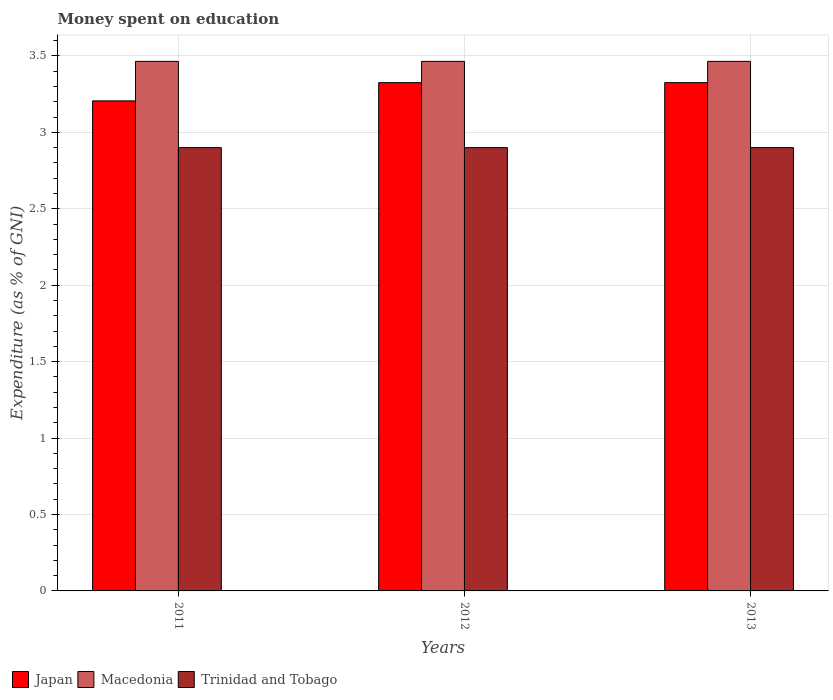How many different coloured bars are there?
Your response must be concise. 3. How many groups of bars are there?
Your answer should be compact. 3. Are the number of bars per tick equal to the number of legend labels?
Offer a very short reply. Yes. Are the number of bars on each tick of the X-axis equal?
Offer a terse response. Yes. In how many cases, is the number of bars for a given year not equal to the number of legend labels?
Provide a succinct answer. 0. What is the amount of money spent on education in Japan in 2011?
Give a very brief answer. 3.21. Across all years, what is the maximum amount of money spent on education in Macedonia?
Offer a very short reply. 3.46. Across all years, what is the minimum amount of money spent on education in Macedonia?
Provide a succinct answer. 3.46. In which year was the amount of money spent on education in Macedonia maximum?
Keep it short and to the point. 2011. In which year was the amount of money spent on education in Macedonia minimum?
Provide a succinct answer. 2011. What is the difference between the amount of money spent on education in Trinidad and Tobago in 2011 and the amount of money spent on education in Japan in 2012?
Provide a short and direct response. -0.43. What is the average amount of money spent on education in Japan per year?
Give a very brief answer. 3.29. In the year 2011, what is the difference between the amount of money spent on education in Trinidad and Tobago and amount of money spent on education in Macedonia?
Ensure brevity in your answer.  -0.56. In how many years, is the amount of money spent on education in Japan greater than 0.30000000000000004 %?
Ensure brevity in your answer.  3. What is the ratio of the amount of money spent on education in Japan in 2012 to that in 2013?
Your answer should be compact. 1. Is the amount of money spent on education in Macedonia in 2011 less than that in 2013?
Ensure brevity in your answer.  No. Is the difference between the amount of money spent on education in Trinidad and Tobago in 2011 and 2013 greater than the difference between the amount of money spent on education in Macedonia in 2011 and 2013?
Make the answer very short. No. What is the difference between the highest and the second highest amount of money spent on education in Trinidad and Tobago?
Provide a short and direct response. 0. What is the difference between the highest and the lowest amount of money spent on education in Japan?
Offer a terse response. 0.12. In how many years, is the amount of money spent on education in Macedonia greater than the average amount of money spent on education in Macedonia taken over all years?
Your response must be concise. 0. What does the 2nd bar from the left in 2011 represents?
Ensure brevity in your answer.  Macedonia. What does the 2nd bar from the right in 2013 represents?
Offer a terse response. Macedonia. How many bars are there?
Offer a very short reply. 9. How many years are there in the graph?
Your answer should be compact. 3. What is the difference between two consecutive major ticks on the Y-axis?
Your answer should be compact. 0.5. Are the values on the major ticks of Y-axis written in scientific E-notation?
Provide a succinct answer. No. How are the legend labels stacked?
Keep it short and to the point. Horizontal. What is the title of the graph?
Offer a terse response. Money spent on education. Does "Maldives" appear as one of the legend labels in the graph?
Give a very brief answer. No. What is the label or title of the Y-axis?
Keep it short and to the point. Expenditure (as % of GNI). What is the Expenditure (as % of GNI) of Japan in 2011?
Keep it short and to the point. 3.21. What is the Expenditure (as % of GNI) of Macedonia in 2011?
Your answer should be compact. 3.46. What is the Expenditure (as % of GNI) of Trinidad and Tobago in 2011?
Give a very brief answer. 2.9. What is the Expenditure (as % of GNI) of Japan in 2012?
Ensure brevity in your answer.  3.33. What is the Expenditure (as % of GNI) in Macedonia in 2012?
Provide a succinct answer. 3.46. What is the Expenditure (as % of GNI) of Trinidad and Tobago in 2012?
Keep it short and to the point. 2.9. What is the Expenditure (as % of GNI) of Japan in 2013?
Provide a succinct answer. 3.33. What is the Expenditure (as % of GNI) of Macedonia in 2013?
Offer a terse response. 3.46. Across all years, what is the maximum Expenditure (as % of GNI) in Japan?
Provide a succinct answer. 3.33. Across all years, what is the maximum Expenditure (as % of GNI) of Macedonia?
Provide a succinct answer. 3.46. Across all years, what is the minimum Expenditure (as % of GNI) of Japan?
Offer a very short reply. 3.21. Across all years, what is the minimum Expenditure (as % of GNI) in Macedonia?
Give a very brief answer. 3.46. What is the total Expenditure (as % of GNI) of Japan in the graph?
Provide a succinct answer. 9.86. What is the total Expenditure (as % of GNI) of Macedonia in the graph?
Make the answer very short. 10.39. What is the total Expenditure (as % of GNI) in Trinidad and Tobago in the graph?
Your answer should be very brief. 8.7. What is the difference between the Expenditure (as % of GNI) of Japan in 2011 and that in 2012?
Your answer should be very brief. -0.12. What is the difference between the Expenditure (as % of GNI) of Japan in 2011 and that in 2013?
Your response must be concise. -0.12. What is the difference between the Expenditure (as % of GNI) in Trinidad and Tobago in 2011 and that in 2013?
Your answer should be very brief. 0. What is the difference between the Expenditure (as % of GNI) in Japan in 2012 and that in 2013?
Ensure brevity in your answer.  0. What is the difference between the Expenditure (as % of GNI) in Macedonia in 2012 and that in 2013?
Offer a very short reply. 0. What is the difference between the Expenditure (as % of GNI) of Trinidad and Tobago in 2012 and that in 2013?
Offer a terse response. 0. What is the difference between the Expenditure (as % of GNI) in Japan in 2011 and the Expenditure (as % of GNI) in Macedonia in 2012?
Give a very brief answer. -0.26. What is the difference between the Expenditure (as % of GNI) of Japan in 2011 and the Expenditure (as % of GNI) of Trinidad and Tobago in 2012?
Keep it short and to the point. 0.31. What is the difference between the Expenditure (as % of GNI) of Macedonia in 2011 and the Expenditure (as % of GNI) of Trinidad and Tobago in 2012?
Offer a very short reply. 0.56. What is the difference between the Expenditure (as % of GNI) of Japan in 2011 and the Expenditure (as % of GNI) of Macedonia in 2013?
Give a very brief answer. -0.26. What is the difference between the Expenditure (as % of GNI) of Japan in 2011 and the Expenditure (as % of GNI) of Trinidad and Tobago in 2013?
Provide a succinct answer. 0.31. What is the difference between the Expenditure (as % of GNI) in Macedonia in 2011 and the Expenditure (as % of GNI) in Trinidad and Tobago in 2013?
Your answer should be compact. 0.56. What is the difference between the Expenditure (as % of GNI) in Japan in 2012 and the Expenditure (as % of GNI) in Macedonia in 2013?
Offer a terse response. -0.14. What is the difference between the Expenditure (as % of GNI) of Japan in 2012 and the Expenditure (as % of GNI) of Trinidad and Tobago in 2013?
Provide a short and direct response. 0.43. What is the difference between the Expenditure (as % of GNI) of Macedonia in 2012 and the Expenditure (as % of GNI) of Trinidad and Tobago in 2013?
Give a very brief answer. 0.56. What is the average Expenditure (as % of GNI) in Japan per year?
Your response must be concise. 3.29. What is the average Expenditure (as % of GNI) in Macedonia per year?
Keep it short and to the point. 3.46. What is the average Expenditure (as % of GNI) in Trinidad and Tobago per year?
Ensure brevity in your answer.  2.9. In the year 2011, what is the difference between the Expenditure (as % of GNI) in Japan and Expenditure (as % of GNI) in Macedonia?
Offer a very short reply. -0.26. In the year 2011, what is the difference between the Expenditure (as % of GNI) in Japan and Expenditure (as % of GNI) in Trinidad and Tobago?
Ensure brevity in your answer.  0.31. In the year 2011, what is the difference between the Expenditure (as % of GNI) of Macedonia and Expenditure (as % of GNI) of Trinidad and Tobago?
Offer a very short reply. 0.56. In the year 2012, what is the difference between the Expenditure (as % of GNI) in Japan and Expenditure (as % of GNI) in Macedonia?
Give a very brief answer. -0.14. In the year 2012, what is the difference between the Expenditure (as % of GNI) of Japan and Expenditure (as % of GNI) of Trinidad and Tobago?
Offer a terse response. 0.43. In the year 2012, what is the difference between the Expenditure (as % of GNI) of Macedonia and Expenditure (as % of GNI) of Trinidad and Tobago?
Offer a terse response. 0.56. In the year 2013, what is the difference between the Expenditure (as % of GNI) of Japan and Expenditure (as % of GNI) of Macedonia?
Your response must be concise. -0.14. In the year 2013, what is the difference between the Expenditure (as % of GNI) of Japan and Expenditure (as % of GNI) of Trinidad and Tobago?
Provide a succinct answer. 0.43. In the year 2013, what is the difference between the Expenditure (as % of GNI) of Macedonia and Expenditure (as % of GNI) of Trinidad and Tobago?
Provide a succinct answer. 0.56. What is the ratio of the Expenditure (as % of GNI) in Japan in 2011 to that in 2012?
Your answer should be very brief. 0.96. What is the ratio of the Expenditure (as % of GNI) in Trinidad and Tobago in 2011 to that in 2012?
Your response must be concise. 1. What is the ratio of the Expenditure (as % of GNI) of Japan in 2011 to that in 2013?
Ensure brevity in your answer.  0.96. What is the ratio of the Expenditure (as % of GNI) in Trinidad and Tobago in 2011 to that in 2013?
Make the answer very short. 1. What is the ratio of the Expenditure (as % of GNI) in Japan in 2012 to that in 2013?
Your answer should be very brief. 1. What is the ratio of the Expenditure (as % of GNI) in Trinidad and Tobago in 2012 to that in 2013?
Make the answer very short. 1. What is the difference between the highest and the second highest Expenditure (as % of GNI) of Japan?
Offer a terse response. 0. What is the difference between the highest and the second highest Expenditure (as % of GNI) in Macedonia?
Provide a succinct answer. 0. What is the difference between the highest and the lowest Expenditure (as % of GNI) in Japan?
Provide a succinct answer. 0.12. What is the difference between the highest and the lowest Expenditure (as % of GNI) in Macedonia?
Make the answer very short. 0. 